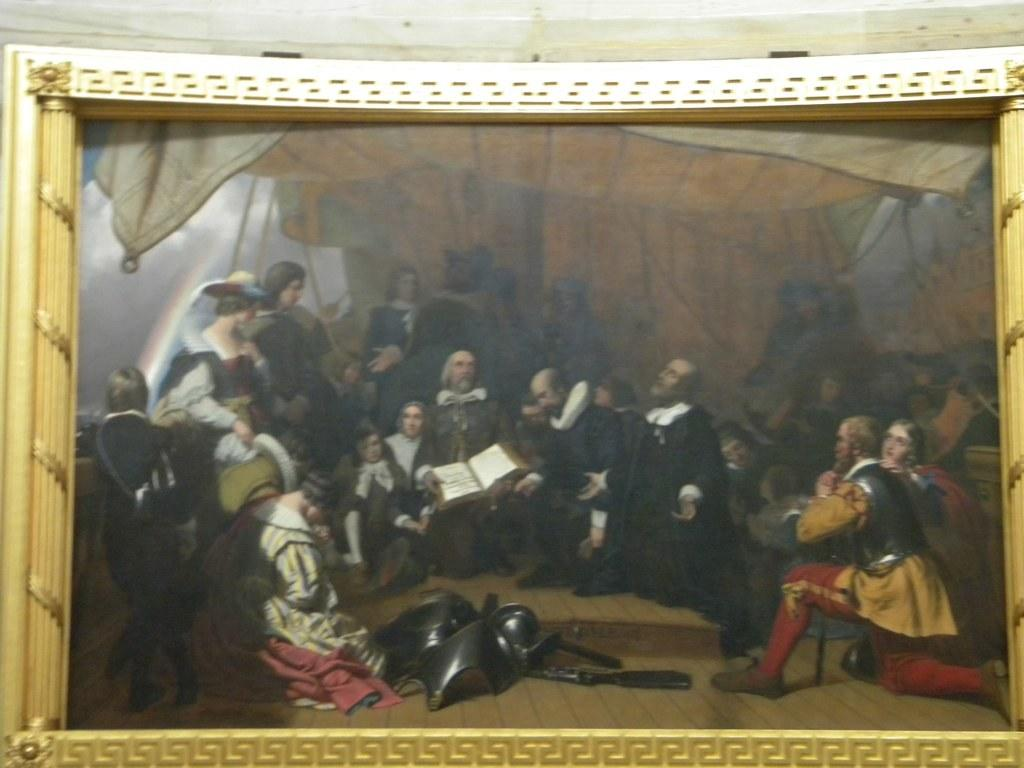What object is present in the image? There is a photo frame in the image. What can be seen inside the photo frame? There are people and tents visible in the photo frame. What type of amusement can be seen in the alley near the tents in the image? There is no alley or amusement present in the image; it only features a photo frame with people and tents. 